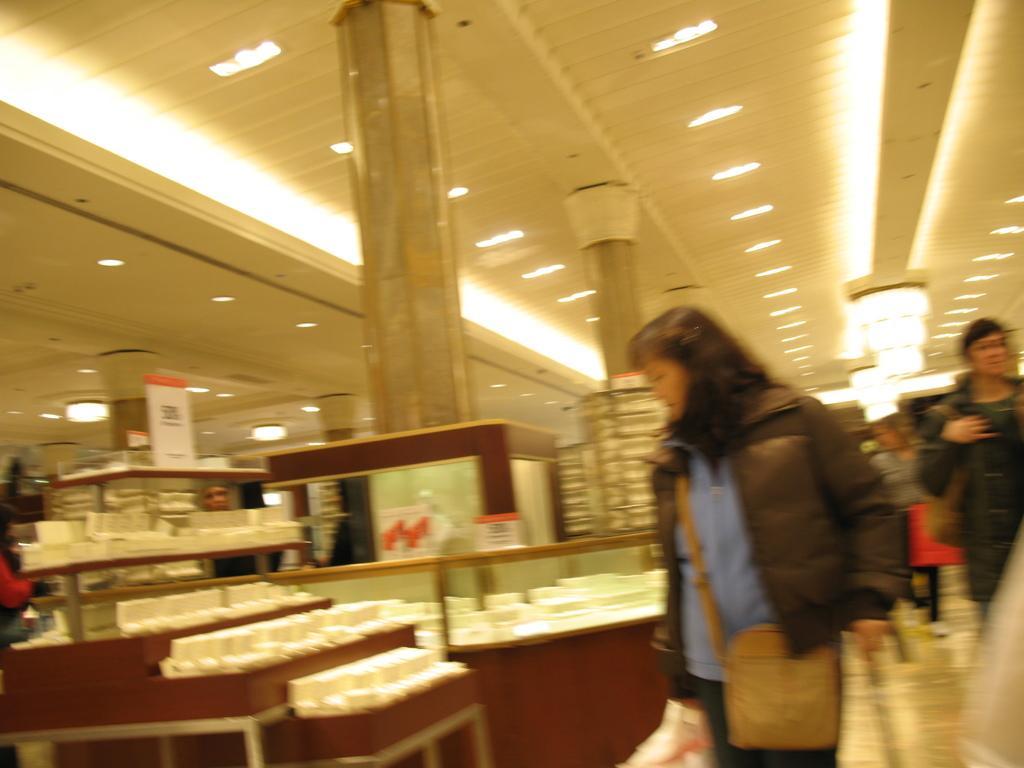Please provide a concise description of this image. In this image there is a woman checking out some objects in a store, behind the woman there are a few other people walking. 